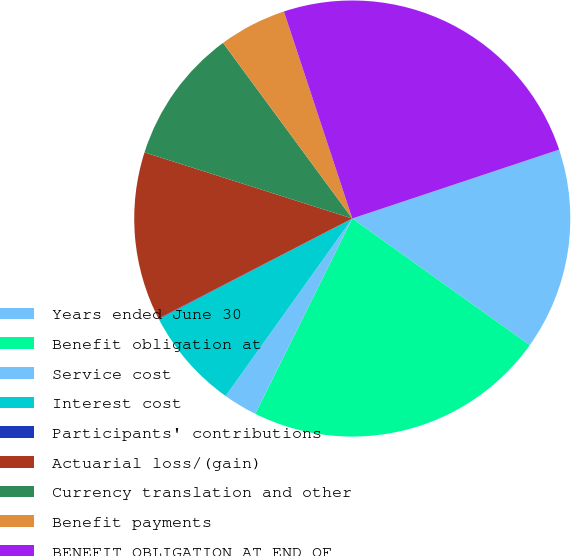<chart> <loc_0><loc_0><loc_500><loc_500><pie_chart><fcel>Years ended June 30<fcel>Benefit obligation at<fcel>Service cost<fcel>Interest cost<fcel>Participants' contributions<fcel>Actuarial loss/(gain)<fcel>Currency translation and other<fcel>Benefit payments<fcel>BENEFIT OBLIGATION AT END OF<nl><fcel>14.98%<fcel>22.47%<fcel>2.53%<fcel>7.51%<fcel>0.04%<fcel>12.49%<fcel>10.0%<fcel>5.02%<fcel>24.96%<nl></chart> 